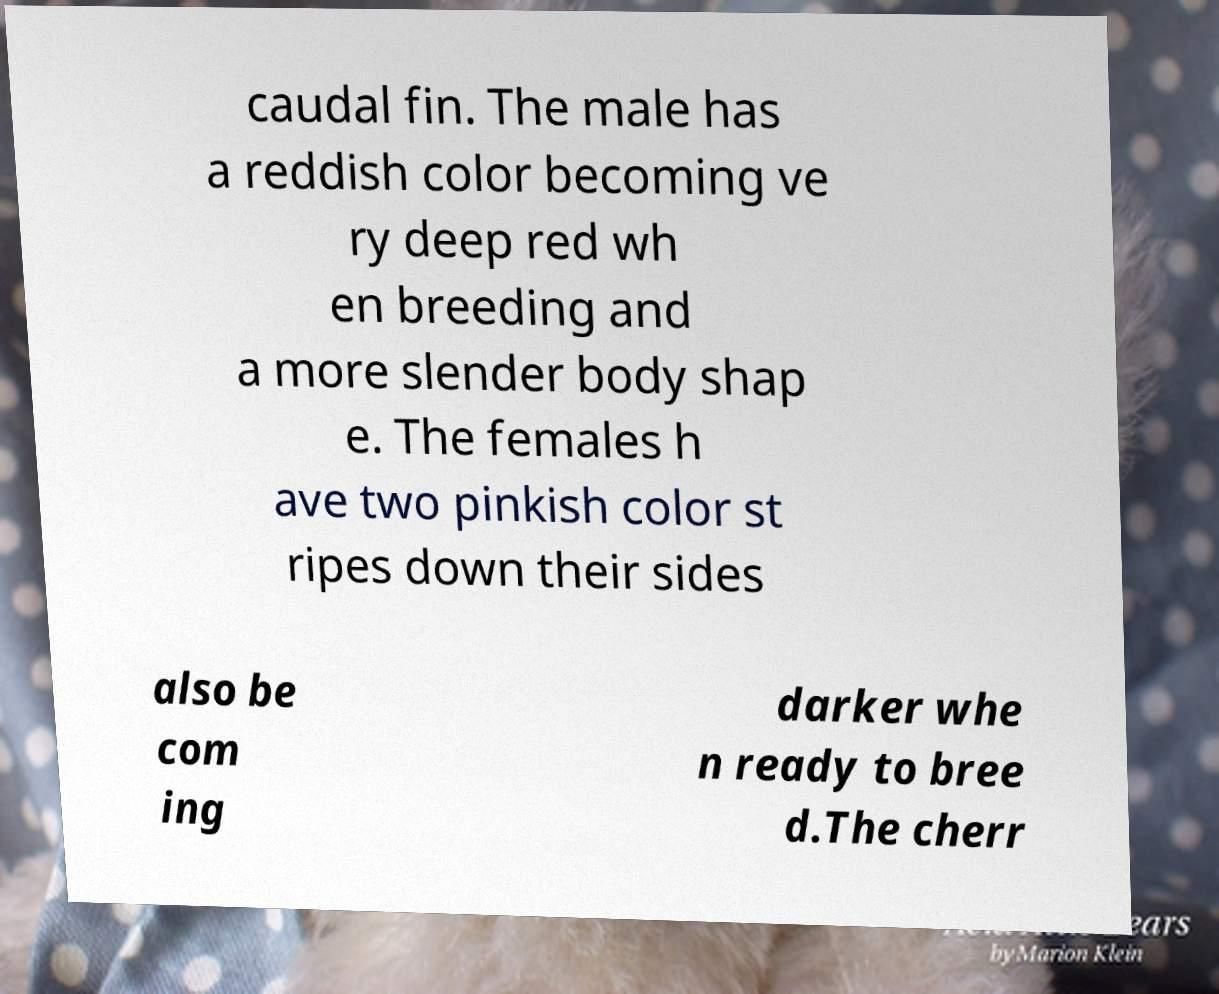Please read and relay the text visible in this image. What does it say? caudal fin. The male has a reddish color becoming ve ry deep red wh en breeding and a more slender body shap e. The females h ave two pinkish color st ripes down their sides also be com ing darker whe n ready to bree d.The cherr 